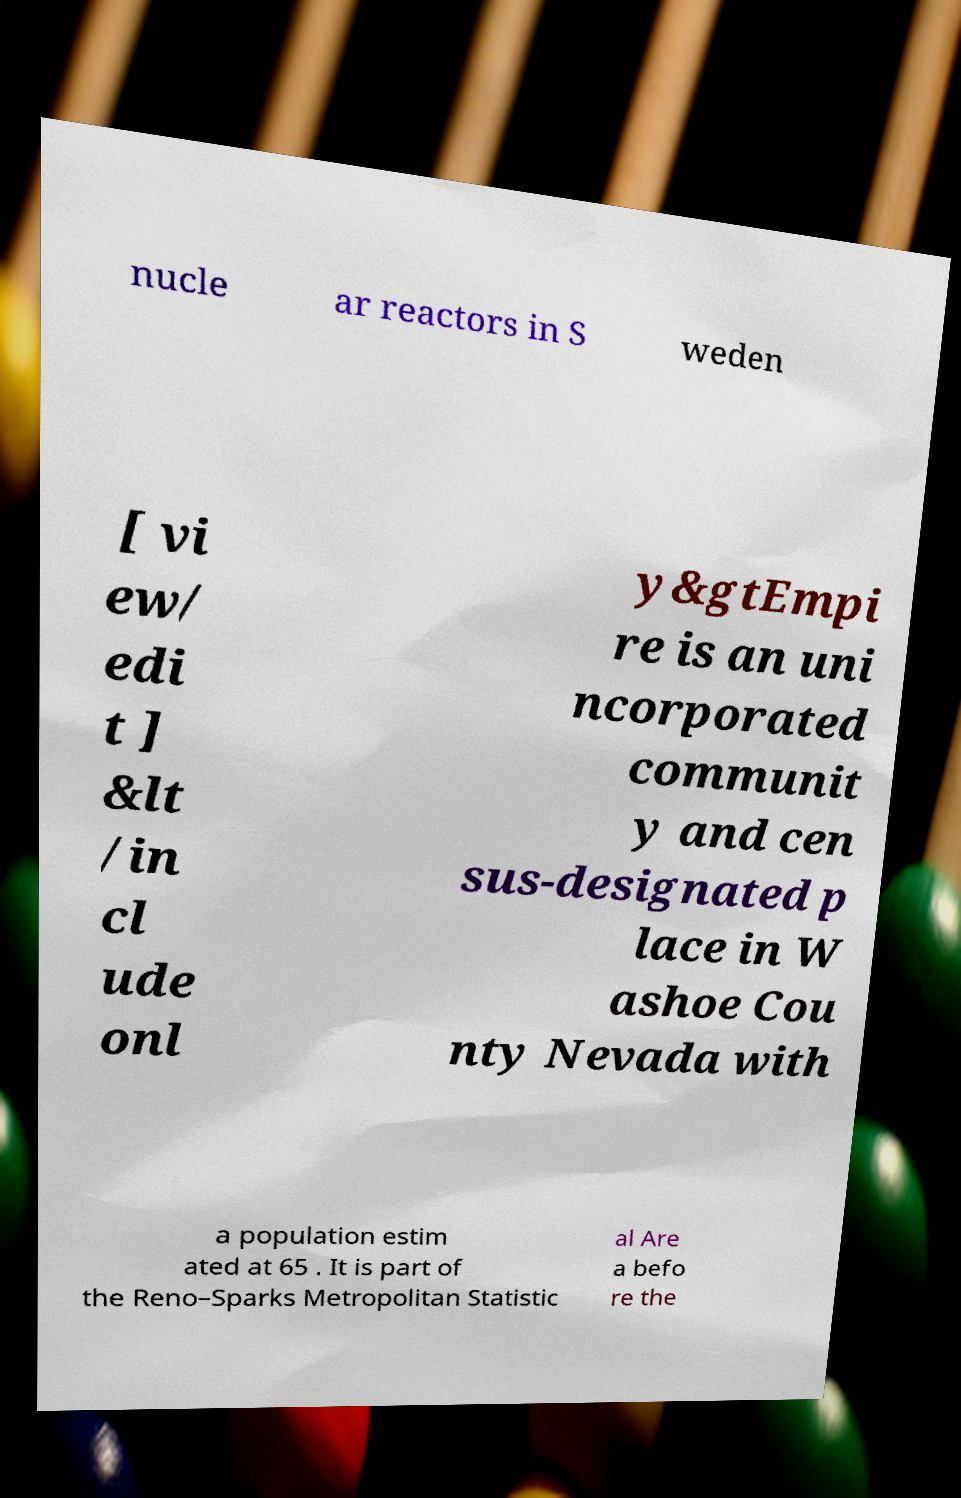Can you accurately transcribe the text from the provided image for me? nucle ar reactors in S weden [ vi ew/ edi t ] &lt /in cl ude onl y&gtEmpi re is an uni ncorporated communit y and cen sus-designated p lace in W ashoe Cou nty Nevada with a population estim ated at 65 . It is part of the Reno–Sparks Metropolitan Statistic al Are a befo re the 